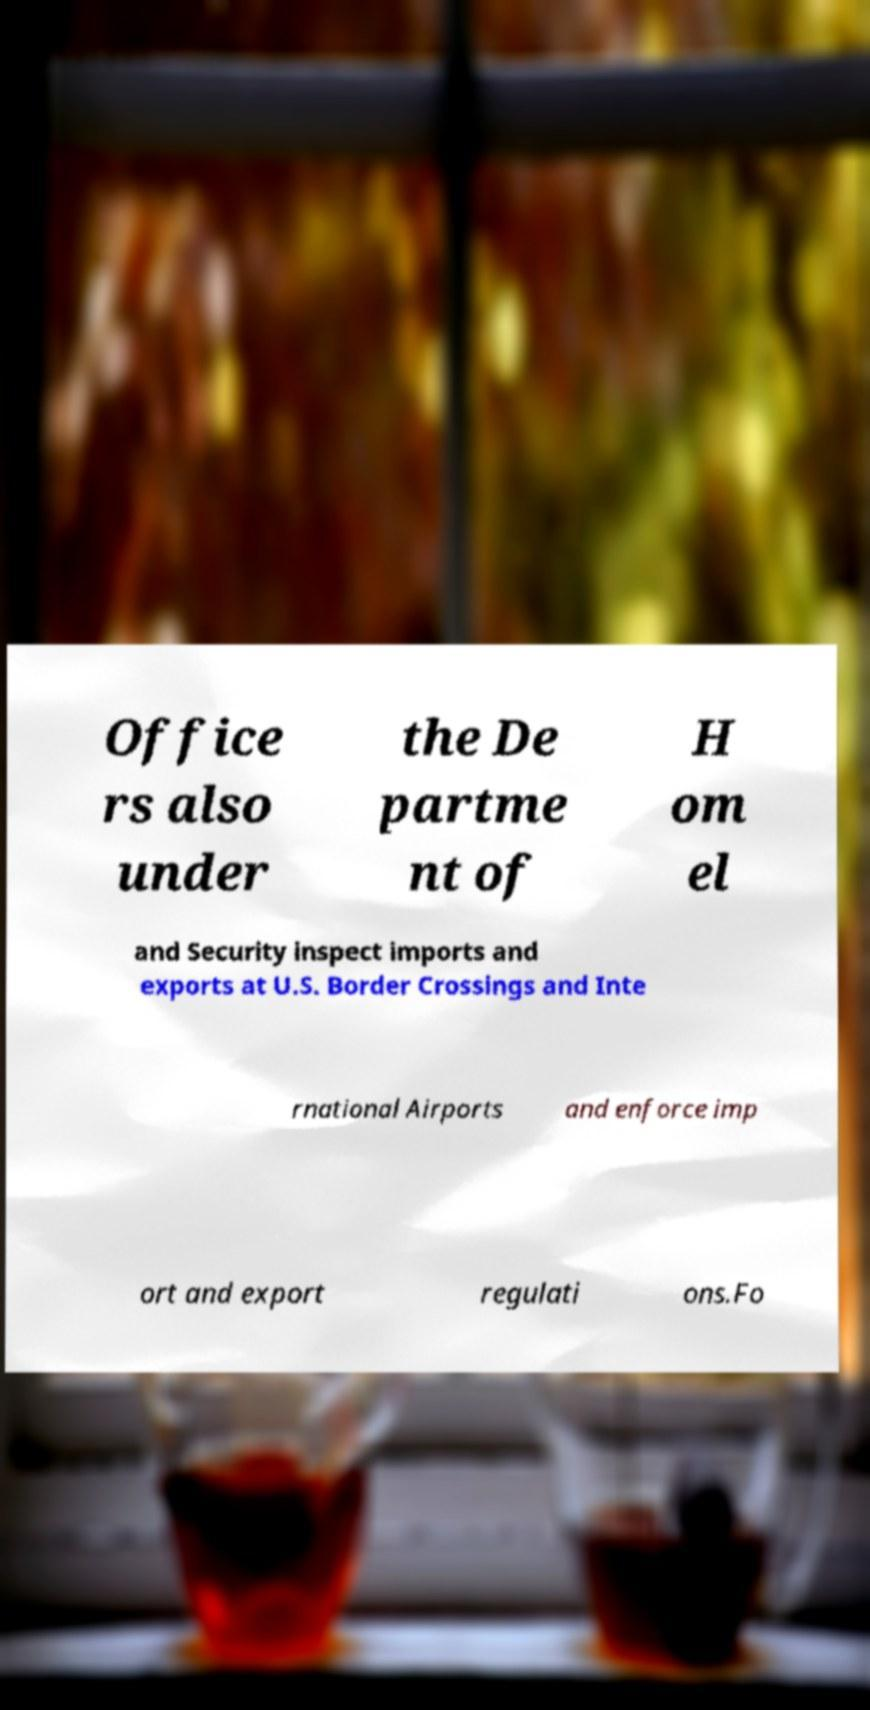There's text embedded in this image that I need extracted. Can you transcribe it verbatim? Office rs also under the De partme nt of H om el and Security inspect imports and exports at U.S. Border Crossings and Inte rnational Airports and enforce imp ort and export regulati ons.Fo 